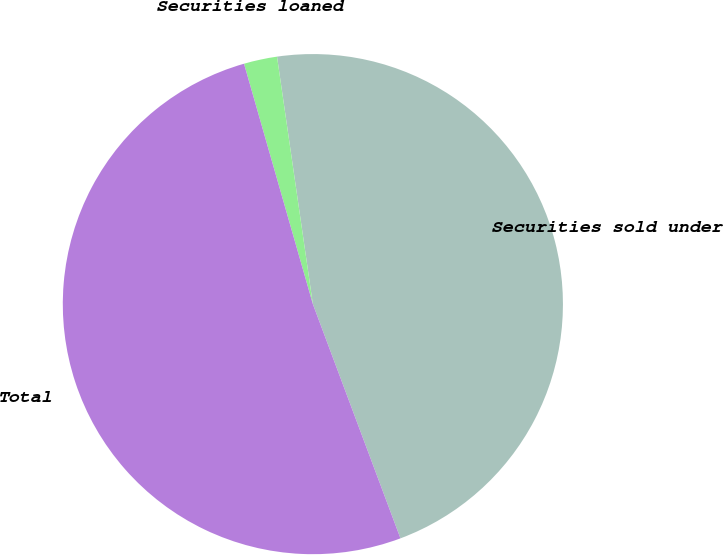Convert chart. <chart><loc_0><loc_0><loc_500><loc_500><pie_chart><fcel>Securities sold under<fcel>Securities loaned<fcel>Total<nl><fcel>46.59%<fcel>2.15%<fcel>51.25%<nl></chart> 